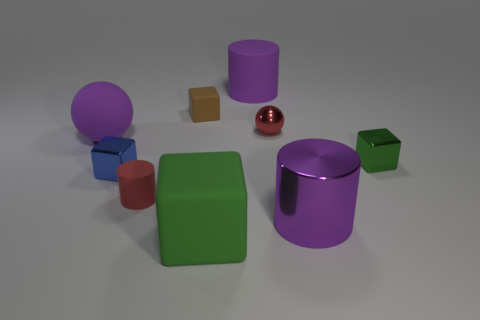How many objects are there in the image, and can you identify their colors? There are seven objects in the image. Starting from the left, we have a purple sphere, a small brown cube, a red cube, a large green cube, a glossy red sphere, a purple cylinder, and a green cube. 